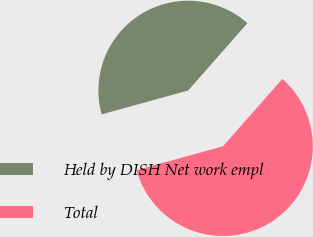Convert chart to OTSL. <chart><loc_0><loc_0><loc_500><loc_500><pie_chart><fcel>Held by DISH Net work empl<fcel>Total<nl><fcel>40.77%<fcel>59.23%<nl></chart> 